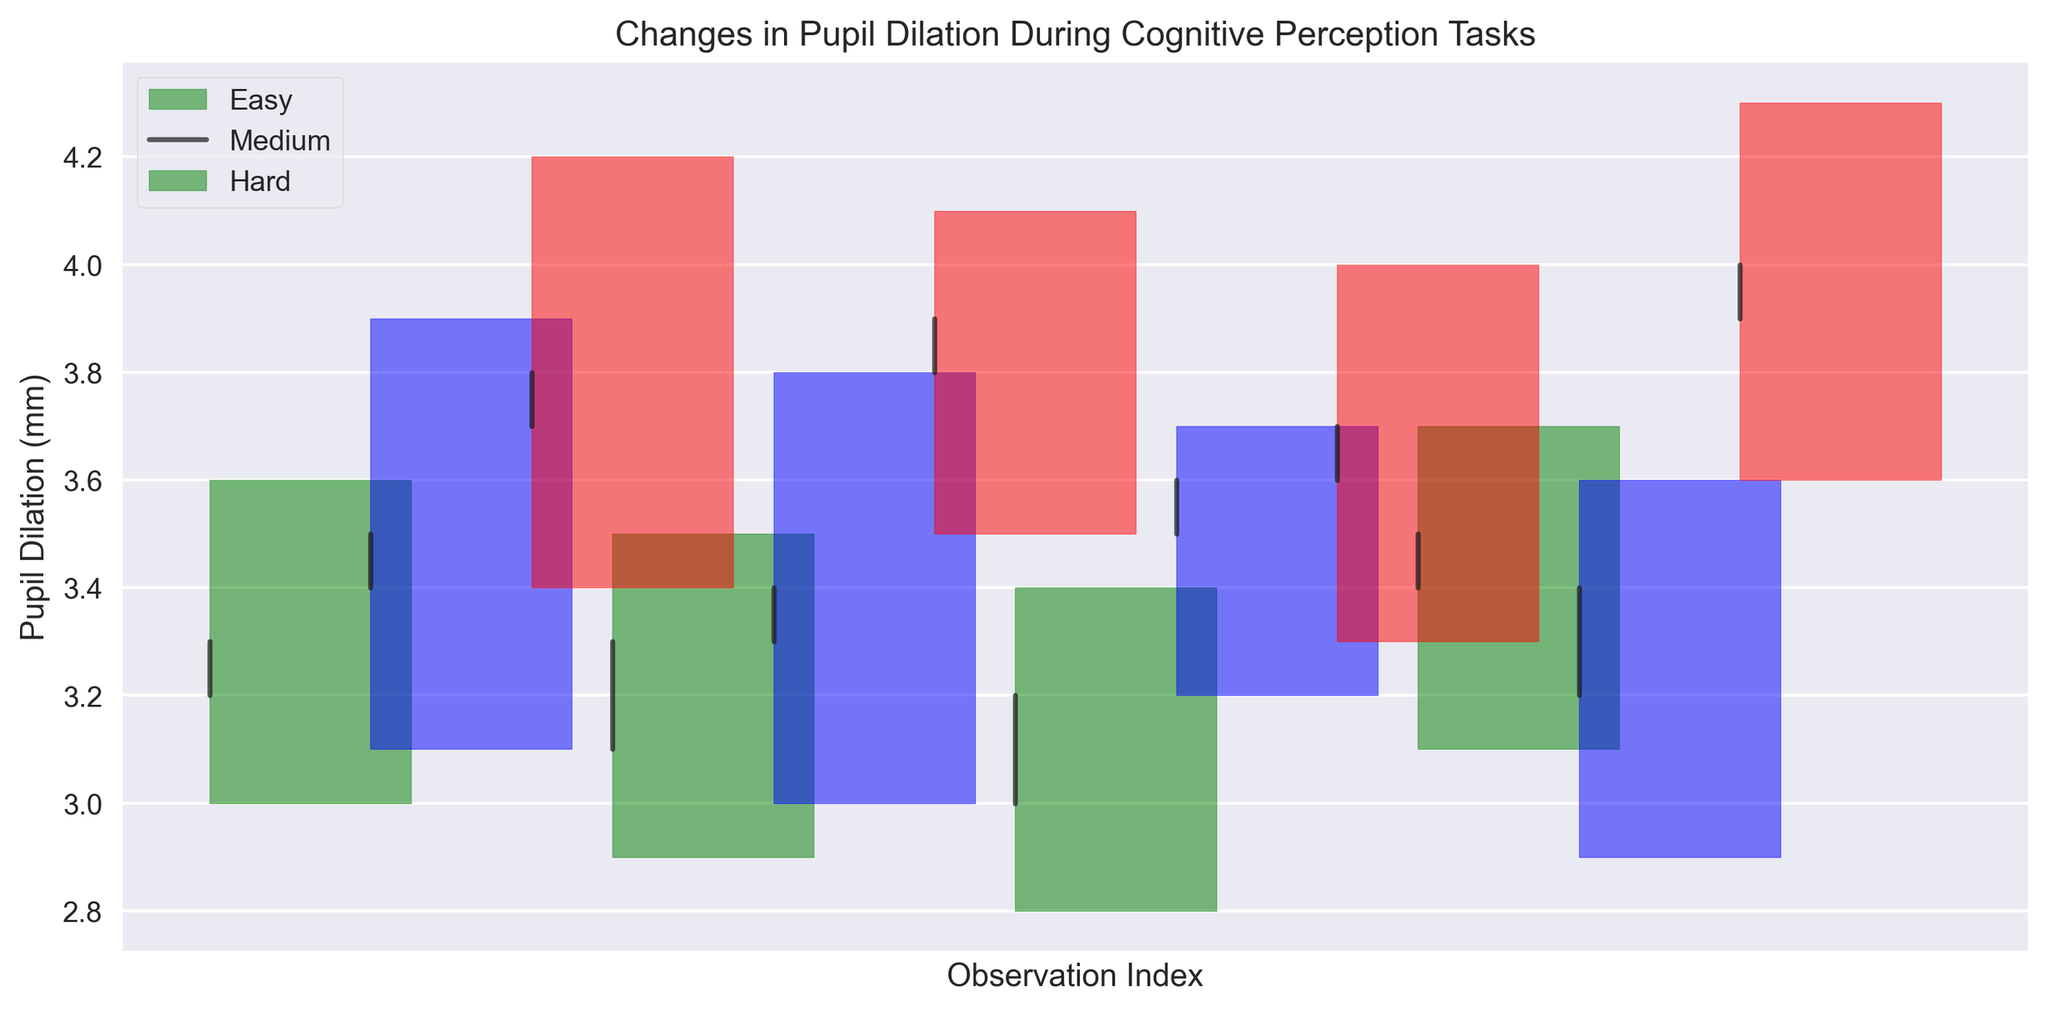Which task shows the highest pupil dilation in a single observation? The highest pupil dilation in a single observation is the topmost point on the chart. The red color represents the "Hard" task, and the highest point labeled in red reaches 4.3 mm.
Answer: Hard Which task shows the smallest range of pupil dilation? The range is calculated as High - Low. For "Easy" (green), ranges are 3.6-3.0, 3.5-2.9, 3.4-2.8, 3.7-3.1 => 0.6, 0.6, 0.6, 0.6. For "Medium" (blue), ranges are 3.9-3.1, 3.8-3.0, 3.7-3.2, 3.6-2.9 => 0.8, 0.8, 0.5, 0.7. For "Hard" (red), ranges are 4.2-3.4, 4.1-3.5, 4.0-3.3, 4.3-3.6 => 0.8, 0.6, 0.7, 0.7. Thus, "Easy" task has the smallest consistent range of 0.6.
Answer: Easy Between the tasks "Medium" and "Hard," which one has a lower minimum pupil dilation? Inspect the lowest point of pupil dilation for each task. For "Medium" (blue), the minimum value is 3.0 mm. For "Hard" (red), the minimum value is 3.3 mm. Therefore, "Medium" has a lower minimum pupil dilation.
Answer: Medium What is the average closing pupil dilation for the "Easy" task? Calculate the average of the Close values for "Easy": (3.3 + 3.3 + 3.2 + 3.5) / 4 = 13.3 / 4 = 3.325 mm.
Answer: 3.325 mm Which task shows the greatest variability in pupil dilation? Variability can be seen by the highest range between Low and High. Compare the ranges: "Easy" has ranges of 0.6 mm, "Medium" ranges between 0.5-0.8 mm, and "Hard" ranges from 0.6-0.8 mm. "Hard" shows the greatest spread considering higher maximum dilation values.
Answer: Hard What color represents the pupil dilation changes for the "Medium" difficulty level? Check the legend or the color-coded bars for "Medium." The bars for "Medium" are colored blue.
Answer: Blue Which task has the greatest increase in pupil dilation from open to close on average? For "Easy": (3.3-3.2 + 3.3-3.1 + 3.2-3.0 + 3.5-3.4) / 4 = 0.2 / 4 = 0.05. For "Medium": (3.5-3.4 + 3.4-3.3 + 3.6-3.5 + 3.4-3.2) / 4 = 0.5 / 4 = 0.125. For "Hard": (3.8-3.7 + 3.9-3.8 + 3.7-3.6 + 4.0-3.9) / 4 = 0.3 / 4 = 0.075. Hence, "Medium" task has the greatest increase.
Answer: Medium 